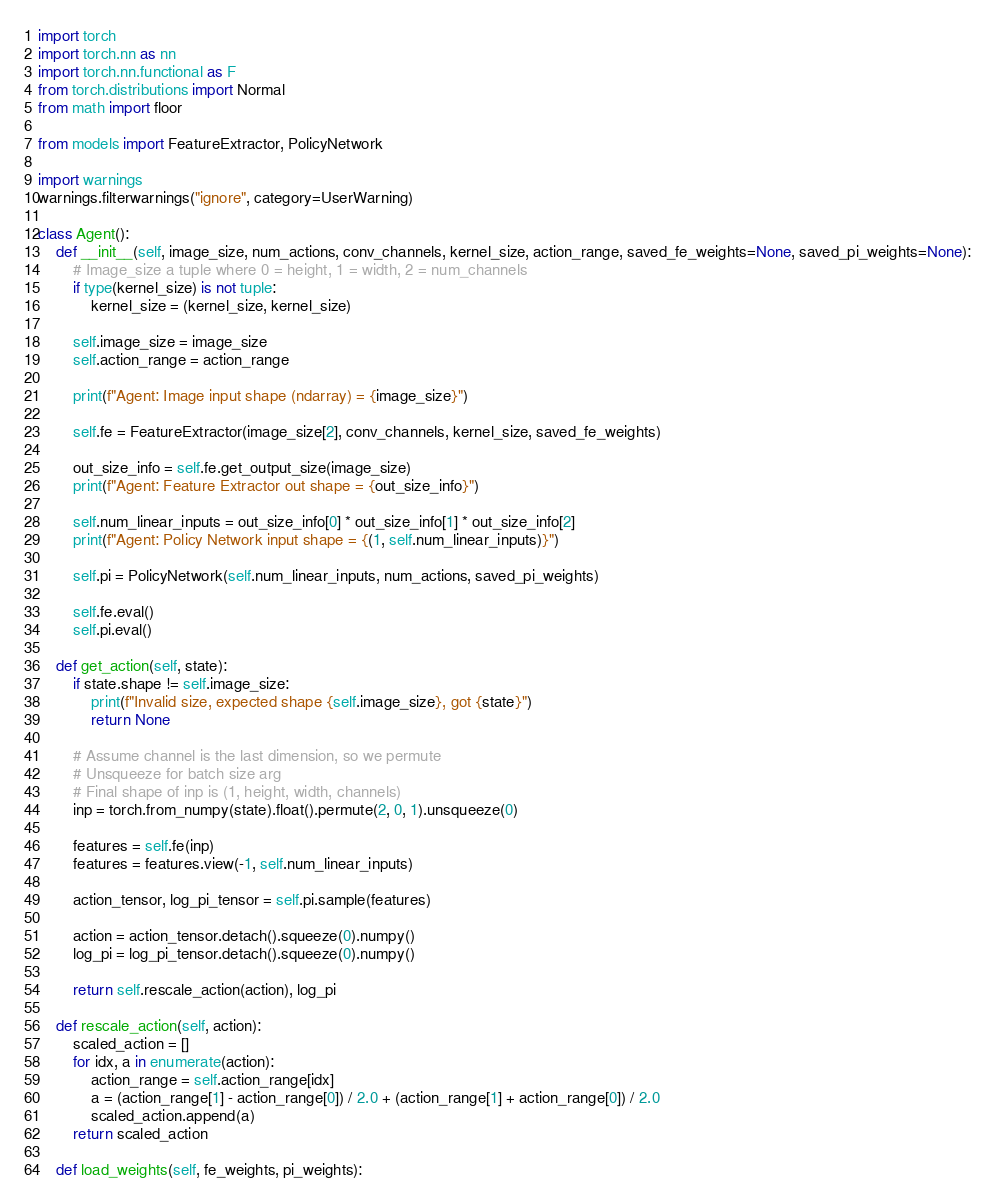Convert code to text. <code><loc_0><loc_0><loc_500><loc_500><_Python_>import torch
import torch.nn as nn
import torch.nn.functional as F
from torch.distributions import Normal
from math import floor

from models import FeatureExtractor, PolicyNetwork

import warnings
warnings.filterwarnings("ignore", category=UserWarning)

class Agent():
    def __init__(self, image_size, num_actions, conv_channels, kernel_size, action_range, saved_fe_weights=None, saved_pi_weights=None):
        # Image_size a tuple where 0 = height, 1 = width, 2 = num_channels
        if type(kernel_size) is not tuple:
            kernel_size = (kernel_size, kernel_size)
        
        self.image_size = image_size
        self.action_range = action_range

        print(f"Agent: Image input shape (ndarray) = {image_size}")

        self.fe = FeatureExtractor(image_size[2], conv_channels, kernel_size, saved_fe_weights)
        
        out_size_info = self.fe.get_output_size(image_size)
        print(f"Agent: Feature Extractor out shape = {out_size_info}")
        
        self.num_linear_inputs = out_size_info[0] * out_size_info[1] * out_size_info[2]
        print(f"Agent: Policy Network input shape = {(1, self.num_linear_inputs)}")

        self.pi = PolicyNetwork(self.num_linear_inputs, num_actions, saved_pi_weights)

        self.fe.eval()
        self.pi.eval()

    def get_action(self, state):
        if state.shape != self.image_size:
            print(f"Invalid size, expected shape {self.image_size}, got {state}")
            return None

        # Assume channel is the last dimension, so we permute
        # Unsqueeze for batch size arg
        # Final shape of inp is (1, height, width, channels)
        inp = torch.from_numpy(state).float().permute(2, 0, 1).unsqueeze(0)

        features = self.fe(inp)
        features = features.view(-1, self.num_linear_inputs)

        action_tensor, log_pi_tensor = self.pi.sample(features)

        action = action_tensor.detach().squeeze(0).numpy()
        log_pi = log_pi_tensor.detach().squeeze(0).numpy()

        return self.rescale_action(action), log_pi

    def rescale_action(self, action):
        scaled_action = []
        for idx, a in enumerate(action):
            action_range = self.action_range[idx]
            a = (action_range[1] - action_range[0]) / 2.0 + (action_range[1] + action_range[0]) / 2.0
            scaled_action.append(a)
        return scaled_action

    def load_weights(self, fe_weights, pi_weights):</code> 